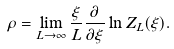<formula> <loc_0><loc_0><loc_500><loc_500>\rho = \lim _ { L \rightarrow \infty } \frac { \xi } { L } \frac { \partial } { \partial \xi } \ln Z _ { L } ( \xi ) .</formula> 